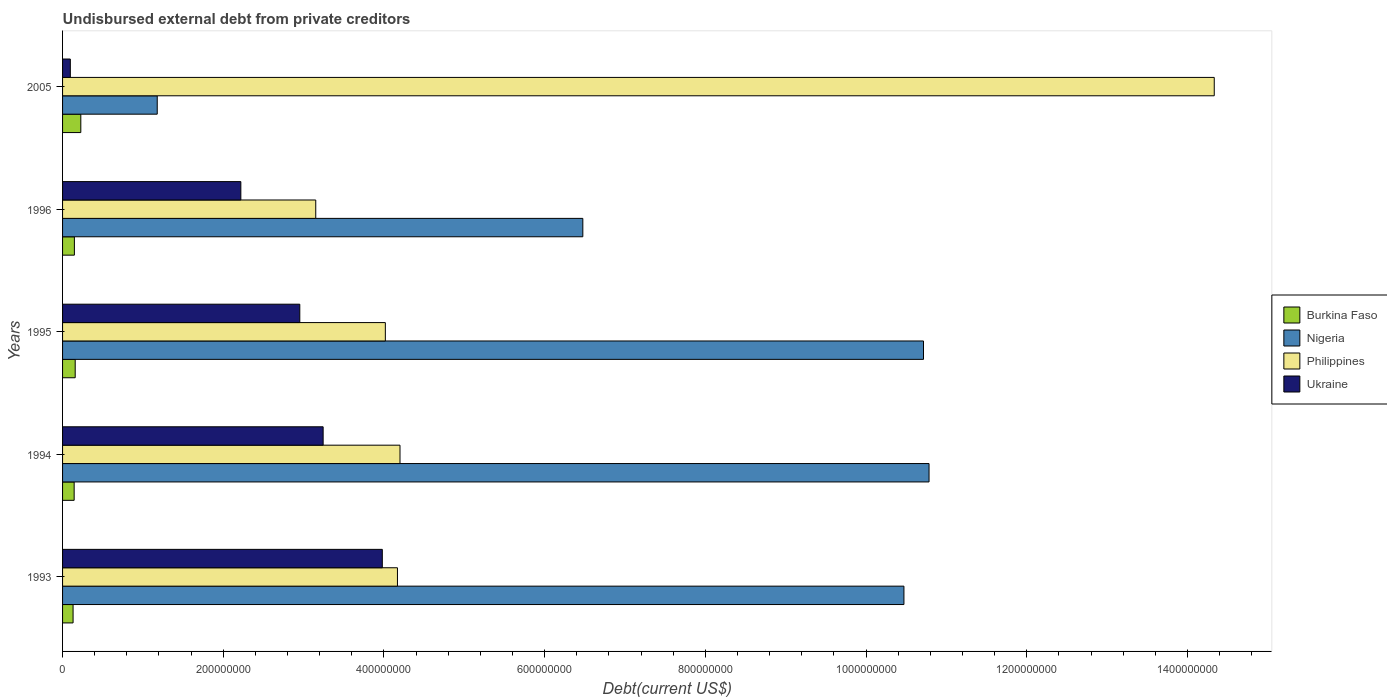How many different coloured bars are there?
Provide a short and direct response. 4. How many groups of bars are there?
Provide a short and direct response. 5. Are the number of bars per tick equal to the number of legend labels?
Provide a short and direct response. Yes. How many bars are there on the 2nd tick from the top?
Your answer should be compact. 4. How many bars are there on the 5th tick from the bottom?
Make the answer very short. 4. What is the label of the 4th group of bars from the top?
Offer a terse response. 1994. What is the total debt in Ukraine in 2005?
Offer a terse response. 9.66e+06. Across all years, what is the maximum total debt in Ukraine?
Provide a succinct answer. 3.98e+08. Across all years, what is the minimum total debt in Philippines?
Keep it short and to the point. 3.15e+08. What is the total total debt in Philippines in the graph?
Keep it short and to the point. 2.99e+09. What is the difference between the total debt in Ukraine in 1994 and that in 1995?
Ensure brevity in your answer.  2.91e+07. What is the difference between the total debt in Philippines in 1994 and the total debt in Nigeria in 1995?
Provide a short and direct response. -6.52e+08. What is the average total debt in Burkina Faso per year?
Make the answer very short. 1.61e+07. In the year 2005, what is the difference between the total debt in Ukraine and total debt in Burkina Faso?
Give a very brief answer. -1.31e+07. In how many years, is the total debt in Burkina Faso greater than 480000000 US$?
Offer a terse response. 0. What is the ratio of the total debt in Ukraine in 1994 to that in 1995?
Give a very brief answer. 1.1. Is the total debt in Burkina Faso in 1995 less than that in 2005?
Offer a terse response. Yes. Is the difference between the total debt in Ukraine in 1996 and 2005 greater than the difference between the total debt in Burkina Faso in 1996 and 2005?
Provide a succinct answer. Yes. What is the difference between the highest and the second highest total debt in Philippines?
Offer a very short reply. 1.01e+09. What is the difference between the highest and the lowest total debt in Burkina Faso?
Give a very brief answer. 9.64e+06. Is the sum of the total debt in Ukraine in 1994 and 2005 greater than the maximum total debt in Nigeria across all years?
Keep it short and to the point. No. Is it the case that in every year, the sum of the total debt in Ukraine and total debt in Burkina Faso is greater than the sum of total debt in Philippines and total debt in Nigeria?
Give a very brief answer. No. What does the 3rd bar from the top in 1996 represents?
Offer a very short reply. Nigeria. What does the 1st bar from the bottom in 1994 represents?
Make the answer very short. Burkina Faso. Is it the case that in every year, the sum of the total debt in Burkina Faso and total debt in Nigeria is greater than the total debt in Ukraine?
Give a very brief answer. Yes. How many bars are there?
Make the answer very short. 20. How many years are there in the graph?
Make the answer very short. 5. How many legend labels are there?
Make the answer very short. 4. What is the title of the graph?
Keep it short and to the point. Undisbursed external debt from private creditors. Does "Marshall Islands" appear as one of the legend labels in the graph?
Give a very brief answer. No. What is the label or title of the X-axis?
Your answer should be compact. Debt(current US$). What is the Debt(current US$) in Burkina Faso in 1993?
Ensure brevity in your answer.  1.31e+07. What is the Debt(current US$) in Nigeria in 1993?
Offer a very short reply. 1.05e+09. What is the Debt(current US$) of Philippines in 1993?
Ensure brevity in your answer.  4.17e+08. What is the Debt(current US$) in Ukraine in 1993?
Your answer should be compact. 3.98e+08. What is the Debt(current US$) of Burkina Faso in 1994?
Ensure brevity in your answer.  1.44e+07. What is the Debt(current US$) of Nigeria in 1994?
Your answer should be very brief. 1.08e+09. What is the Debt(current US$) in Philippines in 1994?
Provide a succinct answer. 4.20e+08. What is the Debt(current US$) in Ukraine in 1994?
Give a very brief answer. 3.24e+08. What is the Debt(current US$) of Burkina Faso in 1995?
Offer a very short reply. 1.57e+07. What is the Debt(current US$) of Nigeria in 1995?
Offer a terse response. 1.07e+09. What is the Debt(current US$) in Philippines in 1995?
Keep it short and to the point. 4.02e+08. What is the Debt(current US$) in Ukraine in 1995?
Provide a succinct answer. 2.95e+08. What is the Debt(current US$) of Burkina Faso in 1996?
Offer a very short reply. 1.47e+07. What is the Debt(current US$) in Nigeria in 1996?
Ensure brevity in your answer.  6.48e+08. What is the Debt(current US$) in Philippines in 1996?
Ensure brevity in your answer.  3.15e+08. What is the Debt(current US$) of Ukraine in 1996?
Your response must be concise. 2.22e+08. What is the Debt(current US$) of Burkina Faso in 2005?
Give a very brief answer. 2.27e+07. What is the Debt(current US$) in Nigeria in 2005?
Offer a terse response. 1.18e+08. What is the Debt(current US$) in Philippines in 2005?
Give a very brief answer. 1.43e+09. What is the Debt(current US$) in Ukraine in 2005?
Make the answer very short. 9.66e+06. Across all years, what is the maximum Debt(current US$) in Burkina Faso?
Ensure brevity in your answer.  2.27e+07. Across all years, what is the maximum Debt(current US$) of Nigeria?
Keep it short and to the point. 1.08e+09. Across all years, what is the maximum Debt(current US$) of Philippines?
Offer a very short reply. 1.43e+09. Across all years, what is the maximum Debt(current US$) in Ukraine?
Make the answer very short. 3.98e+08. Across all years, what is the minimum Debt(current US$) of Burkina Faso?
Provide a short and direct response. 1.31e+07. Across all years, what is the minimum Debt(current US$) in Nigeria?
Provide a short and direct response. 1.18e+08. Across all years, what is the minimum Debt(current US$) of Philippines?
Keep it short and to the point. 3.15e+08. Across all years, what is the minimum Debt(current US$) in Ukraine?
Provide a short and direct response. 9.66e+06. What is the total Debt(current US$) of Burkina Faso in the graph?
Your response must be concise. 8.07e+07. What is the total Debt(current US$) of Nigeria in the graph?
Provide a succinct answer. 3.96e+09. What is the total Debt(current US$) in Philippines in the graph?
Provide a succinct answer. 2.99e+09. What is the total Debt(current US$) of Ukraine in the graph?
Provide a short and direct response. 1.25e+09. What is the difference between the Debt(current US$) of Burkina Faso in 1993 and that in 1994?
Your answer should be compact. -1.34e+06. What is the difference between the Debt(current US$) in Nigeria in 1993 and that in 1994?
Offer a very short reply. -3.12e+07. What is the difference between the Debt(current US$) of Philippines in 1993 and that in 1994?
Your answer should be very brief. -3.17e+06. What is the difference between the Debt(current US$) in Ukraine in 1993 and that in 1994?
Make the answer very short. 7.36e+07. What is the difference between the Debt(current US$) of Burkina Faso in 1993 and that in 1995?
Give a very brief answer. -2.66e+06. What is the difference between the Debt(current US$) of Nigeria in 1993 and that in 1995?
Your answer should be very brief. -2.43e+07. What is the difference between the Debt(current US$) in Philippines in 1993 and that in 1995?
Give a very brief answer. 1.51e+07. What is the difference between the Debt(current US$) of Ukraine in 1993 and that in 1995?
Your answer should be compact. 1.03e+08. What is the difference between the Debt(current US$) of Burkina Faso in 1993 and that in 1996?
Offer a very short reply. -1.64e+06. What is the difference between the Debt(current US$) of Nigeria in 1993 and that in 1996?
Your answer should be compact. 4.00e+08. What is the difference between the Debt(current US$) of Philippines in 1993 and that in 1996?
Your answer should be very brief. 1.02e+08. What is the difference between the Debt(current US$) in Ukraine in 1993 and that in 1996?
Provide a short and direct response. 1.76e+08. What is the difference between the Debt(current US$) in Burkina Faso in 1993 and that in 2005?
Provide a succinct answer. -9.64e+06. What is the difference between the Debt(current US$) of Nigeria in 1993 and that in 2005?
Your answer should be very brief. 9.29e+08. What is the difference between the Debt(current US$) in Philippines in 1993 and that in 2005?
Your answer should be very brief. -1.02e+09. What is the difference between the Debt(current US$) of Ukraine in 1993 and that in 2005?
Ensure brevity in your answer.  3.88e+08. What is the difference between the Debt(current US$) of Burkina Faso in 1994 and that in 1995?
Offer a terse response. -1.31e+06. What is the difference between the Debt(current US$) in Nigeria in 1994 and that in 1995?
Your answer should be very brief. 6.89e+06. What is the difference between the Debt(current US$) in Philippines in 1994 and that in 1995?
Provide a short and direct response. 1.82e+07. What is the difference between the Debt(current US$) in Ukraine in 1994 and that in 1995?
Your answer should be compact. 2.91e+07. What is the difference between the Debt(current US$) in Burkina Faso in 1994 and that in 1996?
Give a very brief answer. -3.01e+05. What is the difference between the Debt(current US$) of Nigeria in 1994 and that in 1996?
Provide a short and direct response. 4.31e+08. What is the difference between the Debt(current US$) in Philippines in 1994 and that in 1996?
Provide a short and direct response. 1.05e+08. What is the difference between the Debt(current US$) in Ukraine in 1994 and that in 1996?
Keep it short and to the point. 1.02e+08. What is the difference between the Debt(current US$) of Burkina Faso in 1994 and that in 2005?
Give a very brief answer. -8.30e+06. What is the difference between the Debt(current US$) in Nigeria in 1994 and that in 2005?
Your answer should be compact. 9.61e+08. What is the difference between the Debt(current US$) in Philippines in 1994 and that in 2005?
Give a very brief answer. -1.01e+09. What is the difference between the Debt(current US$) of Ukraine in 1994 and that in 2005?
Keep it short and to the point. 3.15e+08. What is the difference between the Debt(current US$) of Burkina Faso in 1995 and that in 1996?
Keep it short and to the point. 1.01e+06. What is the difference between the Debt(current US$) of Nigeria in 1995 and that in 1996?
Ensure brevity in your answer.  4.24e+08. What is the difference between the Debt(current US$) of Philippines in 1995 and that in 1996?
Make the answer very short. 8.66e+07. What is the difference between the Debt(current US$) in Ukraine in 1995 and that in 1996?
Your answer should be very brief. 7.34e+07. What is the difference between the Debt(current US$) in Burkina Faso in 1995 and that in 2005?
Provide a short and direct response. -6.98e+06. What is the difference between the Debt(current US$) in Nigeria in 1995 and that in 2005?
Provide a short and direct response. 9.54e+08. What is the difference between the Debt(current US$) of Philippines in 1995 and that in 2005?
Provide a short and direct response. -1.03e+09. What is the difference between the Debt(current US$) of Ukraine in 1995 and that in 2005?
Offer a very short reply. 2.86e+08. What is the difference between the Debt(current US$) of Burkina Faso in 1996 and that in 2005?
Your answer should be very brief. -7.99e+06. What is the difference between the Debt(current US$) of Nigeria in 1996 and that in 2005?
Provide a short and direct response. 5.30e+08. What is the difference between the Debt(current US$) in Philippines in 1996 and that in 2005?
Give a very brief answer. -1.12e+09. What is the difference between the Debt(current US$) in Ukraine in 1996 and that in 2005?
Make the answer very short. 2.12e+08. What is the difference between the Debt(current US$) in Burkina Faso in 1993 and the Debt(current US$) in Nigeria in 1994?
Offer a very short reply. -1.07e+09. What is the difference between the Debt(current US$) in Burkina Faso in 1993 and the Debt(current US$) in Philippines in 1994?
Ensure brevity in your answer.  -4.07e+08. What is the difference between the Debt(current US$) of Burkina Faso in 1993 and the Debt(current US$) of Ukraine in 1994?
Offer a terse response. -3.11e+08. What is the difference between the Debt(current US$) of Nigeria in 1993 and the Debt(current US$) of Philippines in 1994?
Your answer should be very brief. 6.27e+08. What is the difference between the Debt(current US$) of Nigeria in 1993 and the Debt(current US$) of Ukraine in 1994?
Your response must be concise. 7.23e+08. What is the difference between the Debt(current US$) in Philippines in 1993 and the Debt(current US$) in Ukraine in 1994?
Your answer should be very brief. 9.25e+07. What is the difference between the Debt(current US$) of Burkina Faso in 1993 and the Debt(current US$) of Nigeria in 1995?
Keep it short and to the point. -1.06e+09. What is the difference between the Debt(current US$) of Burkina Faso in 1993 and the Debt(current US$) of Philippines in 1995?
Provide a succinct answer. -3.89e+08. What is the difference between the Debt(current US$) of Burkina Faso in 1993 and the Debt(current US$) of Ukraine in 1995?
Your answer should be very brief. -2.82e+08. What is the difference between the Debt(current US$) in Nigeria in 1993 and the Debt(current US$) in Philippines in 1995?
Ensure brevity in your answer.  6.45e+08. What is the difference between the Debt(current US$) of Nigeria in 1993 and the Debt(current US$) of Ukraine in 1995?
Your answer should be compact. 7.52e+08. What is the difference between the Debt(current US$) in Philippines in 1993 and the Debt(current US$) in Ukraine in 1995?
Keep it short and to the point. 1.22e+08. What is the difference between the Debt(current US$) in Burkina Faso in 1993 and the Debt(current US$) in Nigeria in 1996?
Provide a succinct answer. -6.34e+08. What is the difference between the Debt(current US$) of Burkina Faso in 1993 and the Debt(current US$) of Philippines in 1996?
Offer a very short reply. -3.02e+08. What is the difference between the Debt(current US$) in Burkina Faso in 1993 and the Debt(current US$) in Ukraine in 1996?
Ensure brevity in your answer.  -2.09e+08. What is the difference between the Debt(current US$) in Nigeria in 1993 and the Debt(current US$) in Philippines in 1996?
Make the answer very short. 7.32e+08. What is the difference between the Debt(current US$) of Nigeria in 1993 and the Debt(current US$) of Ukraine in 1996?
Provide a succinct answer. 8.25e+08. What is the difference between the Debt(current US$) of Philippines in 1993 and the Debt(current US$) of Ukraine in 1996?
Provide a succinct answer. 1.95e+08. What is the difference between the Debt(current US$) in Burkina Faso in 1993 and the Debt(current US$) in Nigeria in 2005?
Offer a very short reply. -1.05e+08. What is the difference between the Debt(current US$) of Burkina Faso in 1993 and the Debt(current US$) of Philippines in 2005?
Keep it short and to the point. -1.42e+09. What is the difference between the Debt(current US$) of Burkina Faso in 1993 and the Debt(current US$) of Ukraine in 2005?
Provide a succinct answer. 3.42e+06. What is the difference between the Debt(current US$) in Nigeria in 1993 and the Debt(current US$) in Philippines in 2005?
Offer a very short reply. -3.86e+08. What is the difference between the Debt(current US$) in Nigeria in 1993 and the Debt(current US$) in Ukraine in 2005?
Offer a terse response. 1.04e+09. What is the difference between the Debt(current US$) in Philippines in 1993 and the Debt(current US$) in Ukraine in 2005?
Ensure brevity in your answer.  4.07e+08. What is the difference between the Debt(current US$) in Burkina Faso in 1994 and the Debt(current US$) in Nigeria in 1995?
Your answer should be compact. -1.06e+09. What is the difference between the Debt(current US$) in Burkina Faso in 1994 and the Debt(current US$) in Philippines in 1995?
Give a very brief answer. -3.87e+08. What is the difference between the Debt(current US$) of Burkina Faso in 1994 and the Debt(current US$) of Ukraine in 1995?
Provide a short and direct response. -2.81e+08. What is the difference between the Debt(current US$) in Nigeria in 1994 and the Debt(current US$) in Philippines in 1995?
Offer a very short reply. 6.77e+08. What is the difference between the Debt(current US$) of Nigeria in 1994 and the Debt(current US$) of Ukraine in 1995?
Give a very brief answer. 7.83e+08. What is the difference between the Debt(current US$) of Philippines in 1994 and the Debt(current US$) of Ukraine in 1995?
Ensure brevity in your answer.  1.25e+08. What is the difference between the Debt(current US$) in Burkina Faso in 1994 and the Debt(current US$) in Nigeria in 1996?
Offer a terse response. -6.33e+08. What is the difference between the Debt(current US$) in Burkina Faso in 1994 and the Debt(current US$) in Philippines in 1996?
Provide a succinct answer. -3.01e+08. What is the difference between the Debt(current US$) of Burkina Faso in 1994 and the Debt(current US$) of Ukraine in 1996?
Offer a very short reply. -2.07e+08. What is the difference between the Debt(current US$) of Nigeria in 1994 and the Debt(current US$) of Philippines in 1996?
Keep it short and to the point. 7.63e+08. What is the difference between the Debt(current US$) of Nigeria in 1994 and the Debt(current US$) of Ukraine in 1996?
Offer a terse response. 8.57e+08. What is the difference between the Debt(current US$) of Philippines in 1994 and the Debt(current US$) of Ukraine in 1996?
Make the answer very short. 1.98e+08. What is the difference between the Debt(current US$) of Burkina Faso in 1994 and the Debt(current US$) of Nigeria in 2005?
Ensure brevity in your answer.  -1.03e+08. What is the difference between the Debt(current US$) of Burkina Faso in 1994 and the Debt(current US$) of Philippines in 2005?
Your answer should be compact. -1.42e+09. What is the difference between the Debt(current US$) in Burkina Faso in 1994 and the Debt(current US$) in Ukraine in 2005?
Ensure brevity in your answer.  4.76e+06. What is the difference between the Debt(current US$) of Nigeria in 1994 and the Debt(current US$) of Philippines in 2005?
Keep it short and to the point. -3.55e+08. What is the difference between the Debt(current US$) in Nigeria in 1994 and the Debt(current US$) in Ukraine in 2005?
Provide a short and direct response. 1.07e+09. What is the difference between the Debt(current US$) of Philippines in 1994 and the Debt(current US$) of Ukraine in 2005?
Your answer should be very brief. 4.10e+08. What is the difference between the Debt(current US$) in Burkina Faso in 1995 and the Debt(current US$) in Nigeria in 1996?
Your answer should be very brief. -6.32e+08. What is the difference between the Debt(current US$) in Burkina Faso in 1995 and the Debt(current US$) in Philippines in 1996?
Give a very brief answer. -2.99e+08. What is the difference between the Debt(current US$) of Burkina Faso in 1995 and the Debt(current US$) of Ukraine in 1996?
Provide a short and direct response. -2.06e+08. What is the difference between the Debt(current US$) of Nigeria in 1995 and the Debt(current US$) of Philippines in 1996?
Provide a short and direct response. 7.56e+08. What is the difference between the Debt(current US$) in Nigeria in 1995 and the Debt(current US$) in Ukraine in 1996?
Give a very brief answer. 8.50e+08. What is the difference between the Debt(current US$) of Philippines in 1995 and the Debt(current US$) of Ukraine in 1996?
Your response must be concise. 1.80e+08. What is the difference between the Debt(current US$) of Burkina Faso in 1995 and the Debt(current US$) of Nigeria in 2005?
Provide a short and direct response. -1.02e+08. What is the difference between the Debt(current US$) in Burkina Faso in 1995 and the Debt(current US$) in Philippines in 2005?
Ensure brevity in your answer.  -1.42e+09. What is the difference between the Debt(current US$) in Burkina Faso in 1995 and the Debt(current US$) in Ukraine in 2005?
Offer a terse response. 6.08e+06. What is the difference between the Debt(current US$) in Nigeria in 1995 and the Debt(current US$) in Philippines in 2005?
Your response must be concise. -3.62e+08. What is the difference between the Debt(current US$) in Nigeria in 1995 and the Debt(current US$) in Ukraine in 2005?
Provide a short and direct response. 1.06e+09. What is the difference between the Debt(current US$) of Philippines in 1995 and the Debt(current US$) of Ukraine in 2005?
Provide a succinct answer. 3.92e+08. What is the difference between the Debt(current US$) of Burkina Faso in 1996 and the Debt(current US$) of Nigeria in 2005?
Provide a succinct answer. -1.03e+08. What is the difference between the Debt(current US$) of Burkina Faso in 1996 and the Debt(current US$) of Philippines in 2005?
Provide a short and direct response. -1.42e+09. What is the difference between the Debt(current US$) of Burkina Faso in 1996 and the Debt(current US$) of Ukraine in 2005?
Provide a short and direct response. 5.06e+06. What is the difference between the Debt(current US$) of Nigeria in 1996 and the Debt(current US$) of Philippines in 2005?
Your answer should be very brief. -7.86e+08. What is the difference between the Debt(current US$) in Nigeria in 1996 and the Debt(current US$) in Ukraine in 2005?
Offer a terse response. 6.38e+08. What is the difference between the Debt(current US$) of Philippines in 1996 and the Debt(current US$) of Ukraine in 2005?
Your answer should be very brief. 3.05e+08. What is the average Debt(current US$) in Burkina Faso per year?
Provide a short and direct response. 1.61e+07. What is the average Debt(current US$) in Nigeria per year?
Make the answer very short. 7.92e+08. What is the average Debt(current US$) in Philippines per year?
Provide a succinct answer. 5.97e+08. What is the average Debt(current US$) of Ukraine per year?
Give a very brief answer. 2.50e+08. In the year 1993, what is the difference between the Debt(current US$) in Burkina Faso and Debt(current US$) in Nigeria?
Your response must be concise. -1.03e+09. In the year 1993, what is the difference between the Debt(current US$) of Burkina Faso and Debt(current US$) of Philippines?
Offer a terse response. -4.04e+08. In the year 1993, what is the difference between the Debt(current US$) in Burkina Faso and Debt(current US$) in Ukraine?
Make the answer very short. -3.85e+08. In the year 1993, what is the difference between the Debt(current US$) in Nigeria and Debt(current US$) in Philippines?
Offer a terse response. 6.30e+08. In the year 1993, what is the difference between the Debt(current US$) in Nigeria and Debt(current US$) in Ukraine?
Provide a short and direct response. 6.49e+08. In the year 1993, what is the difference between the Debt(current US$) in Philippines and Debt(current US$) in Ukraine?
Make the answer very short. 1.88e+07. In the year 1994, what is the difference between the Debt(current US$) of Burkina Faso and Debt(current US$) of Nigeria?
Provide a short and direct response. -1.06e+09. In the year 1994, what is the difference between the Debt(current US$) of Burkina Faso and Debt(current US$) of Philippines?
Your answer should be very brief. -4.06e+08. In the year 1994, what is the difference between the Debt(current US$) of Burkina Faso and Debt(current US$) of Ukraine?
Ensure brevity in your answer.  -3.10e+08. In the year 1994, what is the difference between the Debt(current US$) in Nigeria and Debt(current US$) in Philippines?
Your answer should be very brief. 6.58e+08. In the year 1994, what is the difference between the Debt(current US$) in Nigeria and Debt(current US$) in Ukraine?
Ensure brevity in your answer.  7.54e+08. In the year 1994, what is the difference between the Debt(current US$) in Philippines and Debt(current US$) in Ukraine?
Offer a terse response. 9.57e+07. In the year 1995, what is the difference between the Debt(current US$) of Burkina Faso and Debt(current US$) of Nigeria?
Offer a very short reply. -1.06e+09. In the year 1995, what is the difference between the Debt(current US$) in Burkina Faso and Debt(current US$) in Philippines?
Make the answer very short. -3.86e+08. In the year 1995, what is the difference between the Debt(current US$) in Burkina Faso and Debt(current US$) in Ukraine?
Offer a very short reply. -2.80e+08. In the year 1995, what is the difference between the Debt(current US$) in Nigeria and Debt(current US$) in Philippines?
Offer a terse response. 6.70e+08. In the year 1995, what is the difference between the Debt(current US$) in Nigeria and Debt(current US$) in Ukraine?
Keep it short and to the point. 7.76e+08. In the year 1995, what is the difference between the Debt(current US$) of Philippines and Debt(current US$) of Ukraine?
Give a very brief answer. 1.06e+08. In the year 1996, what is the difference between the Debt(current US$) in Burkina Faso and Debt(current US$) in Nigeria?
Ensure brevity in your answer.  -6.33e+08. In the year 1996, what is the difference between the Debt(current US$) of Burkina Faso and Debt(current US$) of Philippines?
Your answer should be very brief. -3.00e+08. In the year 1996, what is the difference between the Debt(current US$) of Burkina Faso and Debt(current US$) of Ukraine?
Offer a very short reply. -2.07e+08. In the year 1996, what is the difference between the Debt(current US$) of Nigeria and Debt(current US$) of Philippines?
Provide a short and direct response. 3.32e+08. In the year 1996, what is the difference between the Debt(current US$) of Nigeria and Debt(current US$) of Ukraine?
Offer a very short reply. 4.26e+08. In the year 1996, what is the difference between the Debt(current US$) of Philippines and Debt(current US$) of Ukraine?
Your response must be concise. 9.32e+07. In the year 2005, what is the difference between the Debt(current US$) of Burkina Faso and Debt(current US$) of Nigeria?
Offer a terse response. -9.51e+07. In the year 2005, what is the difference between the Debt(current US$) of Burkina Faso and Debt(current US$) of Philippines?
Your answer should be very brief. -1.41e+09. In the year 2005, what is the difference between the Debt(current US$) in Burkina Faso and Debt(current US$) in Ukraine?
Provide a short and direct response. 1.31e+07. In the year 2005, what is the difference between the Debt(current US$) in Nigeria and Debt(current US$) in Philippines?
Make the answer very short. -1.32e+09. In the year 2005, what is the difference between the Debt(current US$) in Nigeria and Debt(current US$) in Ukraine?
Give a very brief answer. 1.08e+08. In the year 2005, what is the difference between the Debt(current US$) in Philippines and Debt(current US$) in Ukraine?
Give a very brief answer. 1.42e+09. What is the ratio of the Debt(current US$) in Burkina Faso in 1993 to that in 1994?
Make the answer very short. 0.91. What is the ratio of the Debt(current US$) in Philippines in 1993 to that in 1994?
Offer a terse response. 0.99. What is the ratio of the Debt(current US$) of Ukraine in 1993 to that in 1994?
Provide a short and direct response. 1.23. What is the ratio of the Debt(current US$) of Burkina Faso in 1993 to that in 1995?
Your answer should be very brief. 0.83. What is the ratio of the Debt(current US$) in Nigeria in 1993 to that in 1995?
Your answer should be very brief. 0.98. What is the ratio of the Debt(current US$) in Philippines in 1993 to that in 1995?
Offer a terse response. 1.04. What is the ratio of the Debt(current US$) of Ukraine in 1993 to that in 1995?
Provide a short and direct response. 1.35. What is the ratio of the Debt(current US$) of Burkina Faso in 1993 to that in 1996?
Give a very brief answer. 0.89. What is the ratio of the Debt(current US$) in Nigeria in 1993 to that in 1996?
Ensure brevity in your answer.  1.62. What is the ratio of the Debt(current US$) in Philippines in 1993 to that in 1996?
Your response must be concise. 1.32. What is the ratio of the Debt(current US$) of Ukraine in 1993 to that in 1996?
Make the answer very short. 1.79. What is the ratio of the Debt(current US$) in Burkina Faso in 1993 to that in 2005?
Your answer should be very brief. 0.58. What is the ratio of the Debt(current US$) in Nigeria in 1993 to that in 2005?
Give a very brief answer. 8.89. What is the ratio of the Debt(current US$) of Philippines in 1993 to that in 2005?
Ensure brevity in your answer.  0.29. What is the ratio of the Debt(current US$) of Ukraine in 1993 to that in 2005?
Your response must be concise. 41.21. What is the ratio of the Debt(current US$) in Burkina Faso in 1994 to that in 1995?
Your answer should be compact. 0.92. What is the ratio of the Debt(current US$) of Nigeria in 1994 to that in 1995?
Your response must be concise. 1.01. What is the ratio of the Debt(current US$) in Philippines in 1994 to that in 1995?
Your answer should be very brief. 1.05. What is the ratio of the Debt(current US$) of Ukraine in 1994 to that in 1995?
Offer a terse response. 1.1. What is the ratio of the Debt(current US$) in Burkina Faso in 1994 to that in 1996?
Provide a short and direct response. 0.98. What is the ratio of the Debt(current US$) of Nigeria in 1994 to that in 1996?
Provide a succinct answer. 1.67. What is the ratio of the Debt(current US$) in Philippines in 1994 to that in 1996?
Your response must be concise. 1.33. What is the ratio of the Debt(current US$) in Ukraine in 1994 to that in 1996?
Your answer should be compact. 1.46. What is the ratio of the Debt(current US$) of Burkina Faso in 1994 to that in 2005?
Your answer should be very brief. 0.63. What is the ratio of the Debt(current US$) of Nigeria in 1994 to that in 2005?
Ensure brevity in your answer.  9.15. What is the ratio of the Debt(current US$) of Philippines in 1994 to that in 2005?
Your answer should be compact. 0.29. What is the ratio of the Debt(current US$) in Ukraine in 1994 to that in 2005?
Make the answer very short. 33.59. What is the ratio of the Debt(current US$) of Burkina Faso in 1995 to that in 1996?
Provide a succinct answer. 1.07. What is the ratio of the Debt(current US$) of Nigeria in 1995 to that in 1996?
Make the answer very short. 1.65. What is the ratio of the Debt(current US$) in Philippines in 1995 to that in 1996?
Give a very brief answer. 1.27. What is the ratio of the Debt(current US$) in Ukraine in 1995 to that in 1996?
Your response must be concise. 1.33. What is the ratio of the Debt(current US$) of Burkina Faso in 1995 to that in 2005?
Ensure brevity in your answer.  0.69. What is the ratio of the Debt(current US$) of Nigeria in 1995 to that in 2005?
Make the answer very short. 9.09. What is the ratio of the Debt(current US$) of Philippines in 1995 to that in 2005?
Ensure brevity in your answer.  0.28. What is the ratio of the Debt(current US$) in Ukraine in 1995 to that in 2005?
Ensure brevity in your answer.  30.58. What is the ratio of the Debt(current US$) of Burkina Faso in 1996 to that in 2005?
Keep it short and to the point. 0.65. What is the ratio of the Debt(current US$) of Nigeria in 1996 to that in 2005?
Offer a terse response. 5.5. What is the ratio of the Debt(current US$) in Philippines in 1996 to that in 2005?
Your answer should be very brief. 0.22. What is the ratio of the Debt(current US$) of Ukraine in 1996 to that in 2005?
Offer a very short reply. 22.98. What is the difference between the highest and the second highest Debt(current US$) of Burkina Faso?
Your answer should be very brief. 6.98e+06. What is the difference between the highest and the second highest Debt(current US$) in Nigeria?
Offer a very short reply. 6.89e+06. What is the difference between the highest and the second highest Debt(current US$) in Philippines?
Keep it short and to the point. 1.01e+09. What is the difference between the highest and the second highest Debt(current US$) in Ukraine?
Your answer should be very brief. 7.36e+07. What is the difference between the highest and the lowest Debt(current US$) in Burkina Faso?
Your answer should be very brief. 9.64e+06. What is the difference between the highest and the lowest Debt(current US$) in Nigeria?
Provide a succinct answer. 9.61e+08. What is the difference between the highest and the lowest Debt(current US$) in Philippines?
Offer a terse response. 1.12e+09. What is the difference between the highest and the lowest Debt(current US$) of Ukraine?
Offer a very short reply. 3.88e+08. 